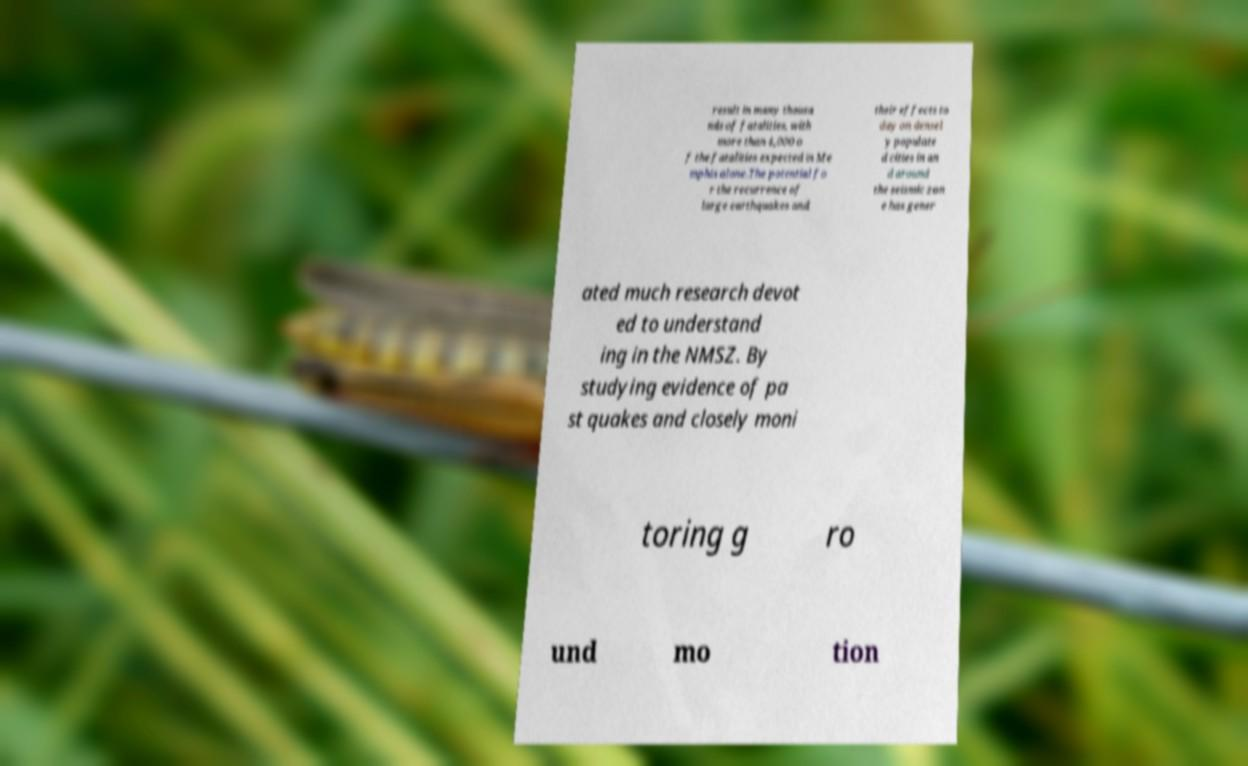There's text embedded in this image that I need extracted. Can you transcribe it verbatim? result in many thousa nds of fatalities, with more than 4,000 o f the fatalities expected in Me mphis alone.The potential fo r the recurrence of large earthquakes and their effects to day on densel y populate d cities in an d around the seismic zon e has gener ated much research devot ed to understand ing in the NMSZ. By studying evidence of pa st quakes and closely moni toring g ro und mo tion 